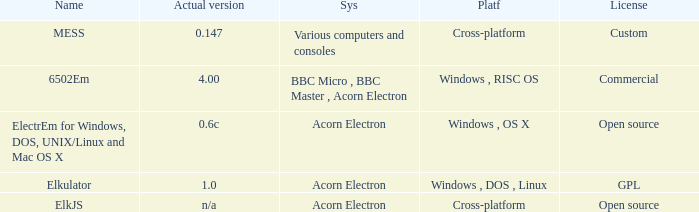What is the name of the platform used for various computers and consoles? Cross-platform. 